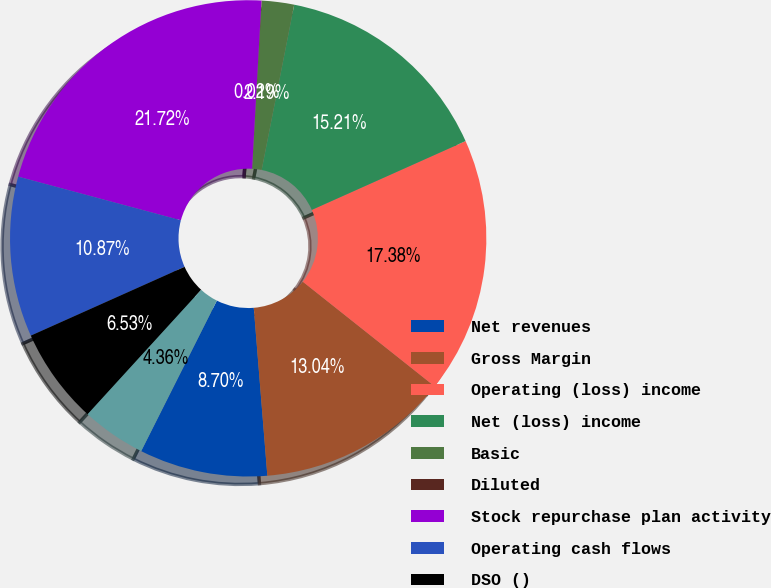<chart> <loc_0><loc_0><loc_500><loc_500><pie_chart><fcel>Net revenues<fcel>Gross Margin<fcel>Operating (loss) income<fcel>Net (loss) income<fcel>Basic<fcel>Diluted<fcel>Stock repurchase plan activity<fcel>Operating cash flows<fcel>DSO ()<fcel>Deferred revenue<nl><fcel>8.7%<fcel>13.04%<fcel>17.38%<fcel>15.21%<fcel>2.19%<fcel>0.02%<fcel>21.72%<fcel>10.87%<fcel>6.53%<fcel>4.36%<nl></chart> 